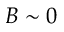<formula> <loc_0><loc_0><loc_500><loc_500>B \sim 0</formula> 